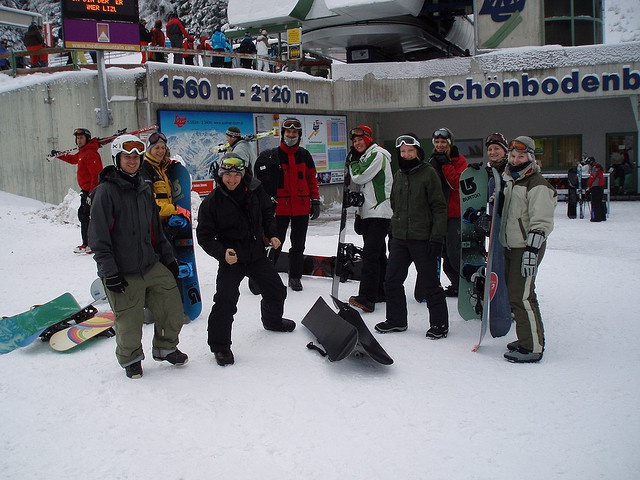Describe the objects in this image and their specific colors. I can see people in navy, black, gray, and maroon tones, people in navy, black, gray, brown, and maroon tones, people in navy, black, gray, brown, and darkgray tones, people in navy, black, gray, and maroon tones, and people in black, maroon, gray, and darkgray tones in this image. 